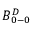Convert formula to latex. <formula><loc_0><loc_0><loc_500><loc_500>B _ { 0 - 0 } ^ { D }</formula> 